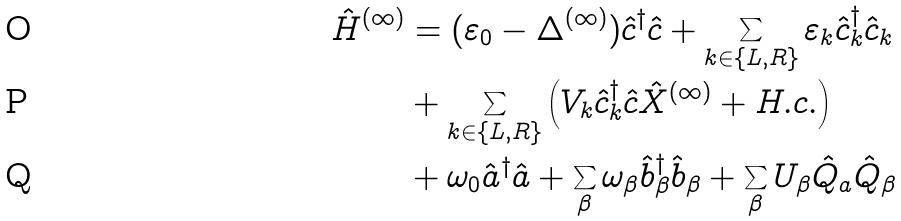Convert formula to latex. <formula><loc_0><loc_0><loc_500><loc_500>\hat { H } ^ { ( \infty ) } & = ( \varepsilon _ { 0 } - \Delta ^ { ( \infty ) } ) \hat { c } ^ { \dagger } \hat { c } + \sum _ { k \in \{ L , R \} } \varepsilon _ { k } \hat { c } _ { k } ^ { \dagger } \hat { c } _ { k } \\ & + \sum _ { k \in \{ L , R \} } \left ( V _ { k } \hat { c } _ { k } ^ { \dagger } \hat { c } \hat { X } ^ { ( \infty ) } + H . c . \right ) \\ & + \omega _ { 0 } \hat { a } ^ { \dagger } \hat { a } + \sum _ { \beta } \omega _ { \beta } \hat { b } ^ { \dagger } _ { \beta } \hat { b } _ { \beta } + \sum _ { \beta } U _ { \beta } \hat { Q } _ { a } \hat { Q } _ { \beta }</formula> 